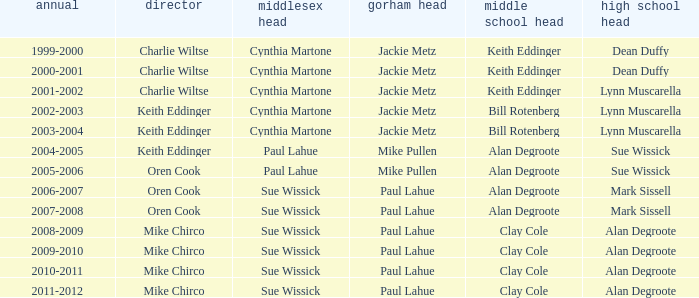Who were the middle school principal(s) in 2010-2011? Clay Cole. 